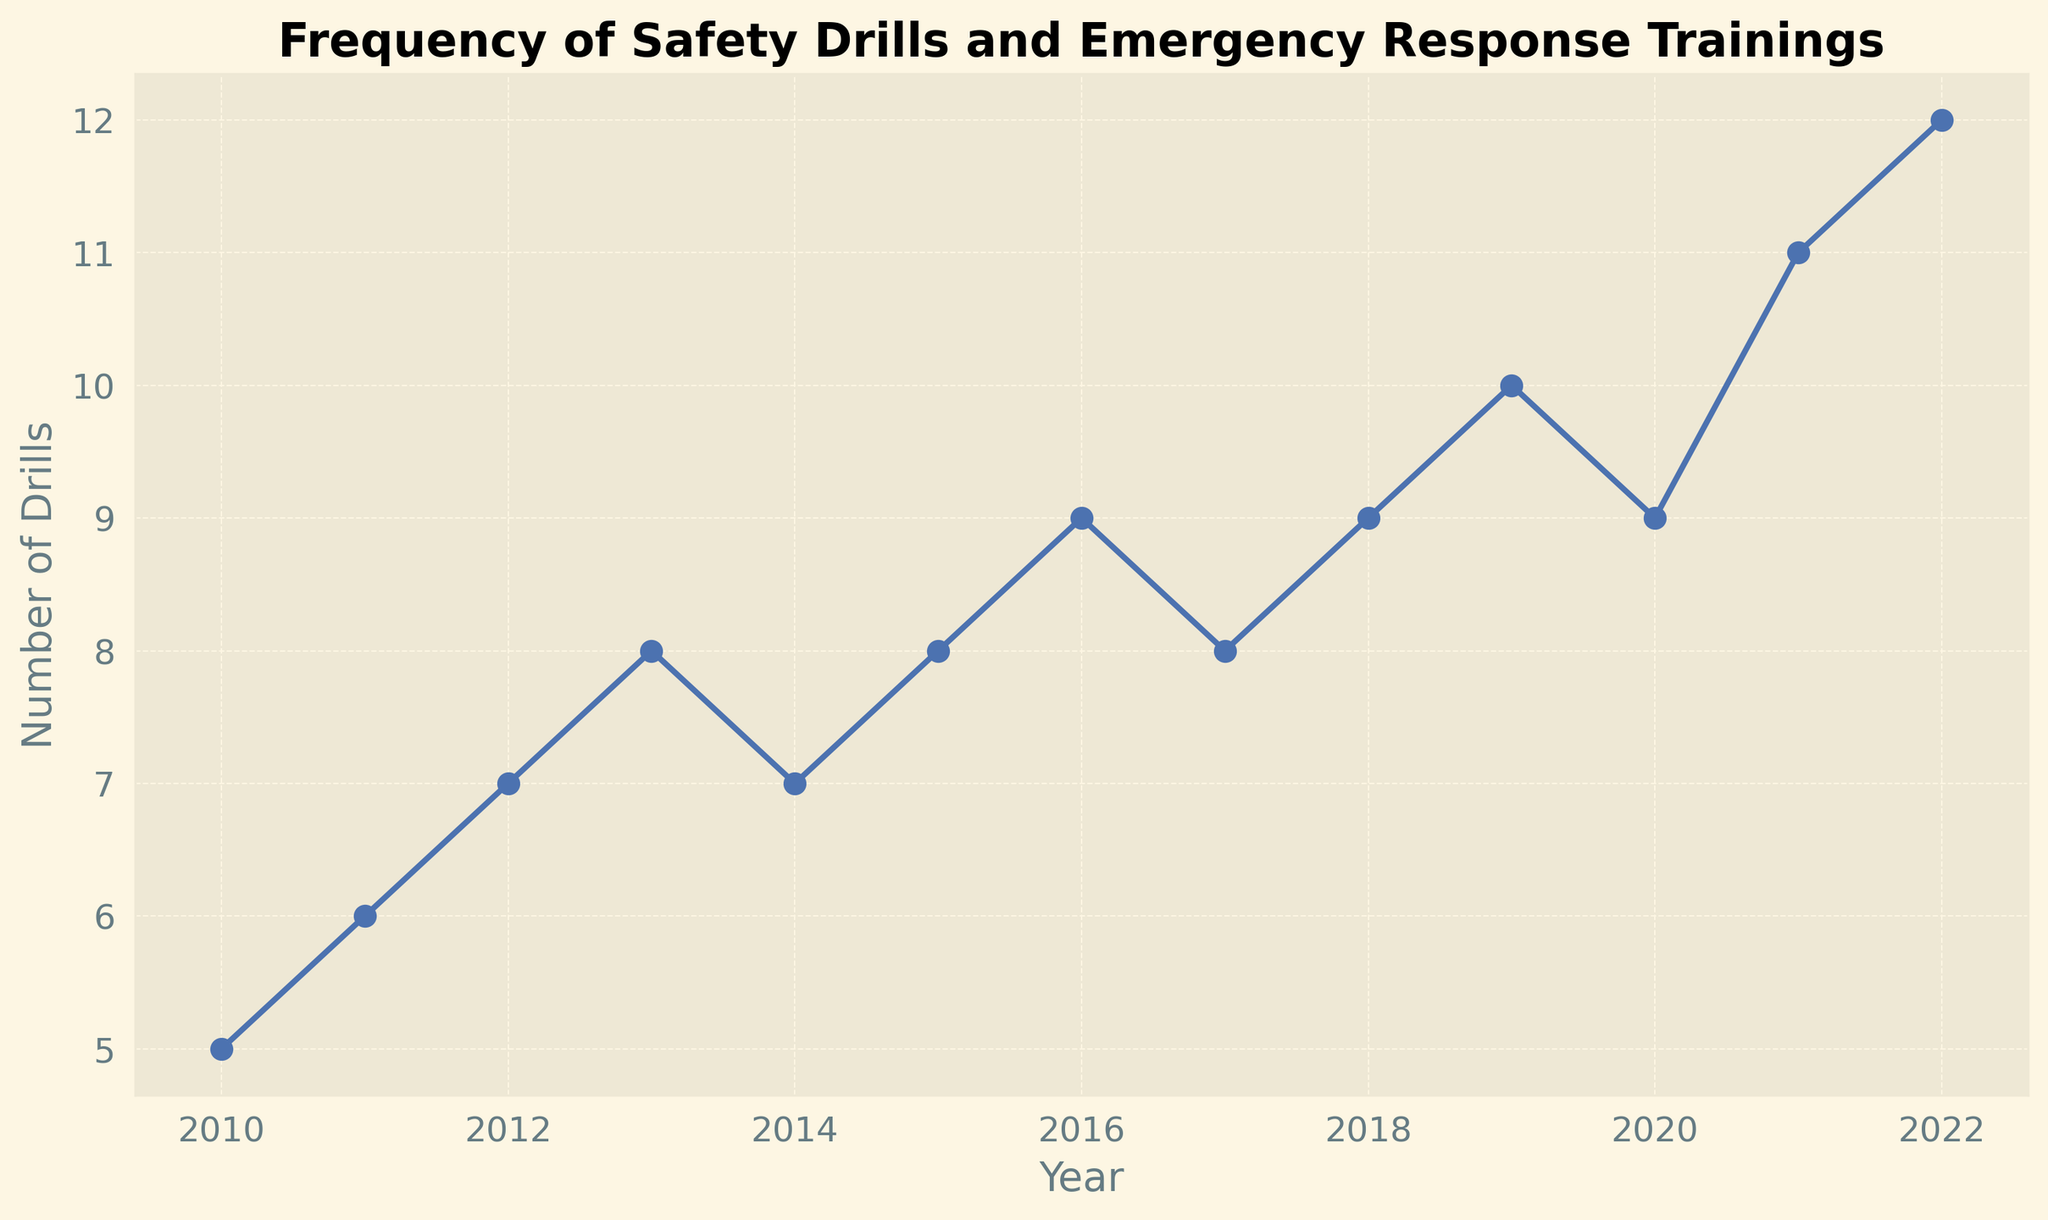How many drills were conducted in 2015? To find the number of drills in a specific year, we locate the year on the x-axis and read the corresponding value on the y-axis. For 2015, the value on the y-axis is 8.
Answer: 8 What is the difference in the number of drills between 2016 and 2020? Find the number of drills for each year on the y-axis: 2016 (9) and 2020 (9). Then, subtract the 2016 value from the 2020 value: 9 - 9 = 0.
Answer: 0 Which year had the highest number of drills? Look for the peak point on the plot where the y-axis value is at its highest. The highest number is 12, which occurs in 2022.
Answer: 2022 Did any year have the same number of drills as the previous year? Check if two consecutive years have the same y-axis value. The y-axis values for 2015 (8) and 2017 (8) are the same.
Answer: Yes What is the average number of drills over the entire period? Sum all the y-axis values: 5 + 6 + 7 + 8 + 7 + 8 + 9 + 8 + 9 + 10 + 9 + 11 + 12 = 109. Then, divide by the number of years (13): 109 / 13 ≈ 8.38.
Answer: 8.38 By how many drills did the number increase from 2011 to 2021? Find the drills for each year: 2011 (6) and 2021 (11). Subtract the 2011 value from the 2021 value: 11 - 6 = 5.
Answer: 5 Is there a year where the number of drills decreased compared to the previous year? Look for y-axis value drops between consecutive years. In 2014, the value dropped from 8 (2013) to 7.
Answer: Yes What is the trend in the frequency of drills from 2010 to 2022? The general trend can be observed by looking at the overall direction of the line. The line starts at 5 in 2010 and generally increases to 12 in 2022.
Answer: Increasing What's the total number of drills conducted from 2018 to 2020 inclusive? Sum the values for 2018 (9), 2019 (10), and 2020 (9): 9 + 10 + 9 = 28.
Answer: 28 